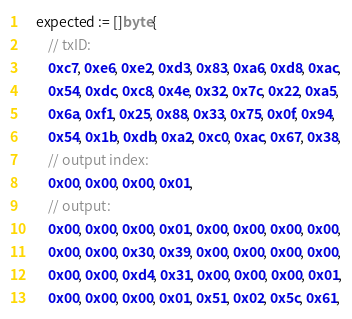<code> <loc_0><loc_0><loc_500><loc_500><_Go_>
	expected := []byte{
		// txID:
		0xc7, 0xe6, 0xe2, 0xd3, 0x83, 0xa6, 0xd8, 0xac,
		0x54, 0xdc, 0xc8, 0x4e, 0x32, 0x7c, 0x22, 0xa5,
		0x6a, 0xf1, 0x25, 0x88, 0x33, 0x75, 0x0f, 0x94,
		0x54, 0x1b, 0xdb, 0xa2, 0xc0, 0xac, 0x67, 0x38,
		// output index:
		0x00, 0x00, 0x00, 0x01,
		// output:
		0x00, 0x00, 0x00, 0x01, 0x00, 0x00, 0x00, 0x00,
		0x00, 0x00, 0x30, 0x39, 0x00, 0x00, 0x00, 0x00,
		0x00, 0x00, 0xd4, 0x31, 0x00, 0x00, 0x00, 0x01,
		0x00, 0x00, 0x00, 0x01, 0x51, 0x02, 0x5c, 0x61,</code> 